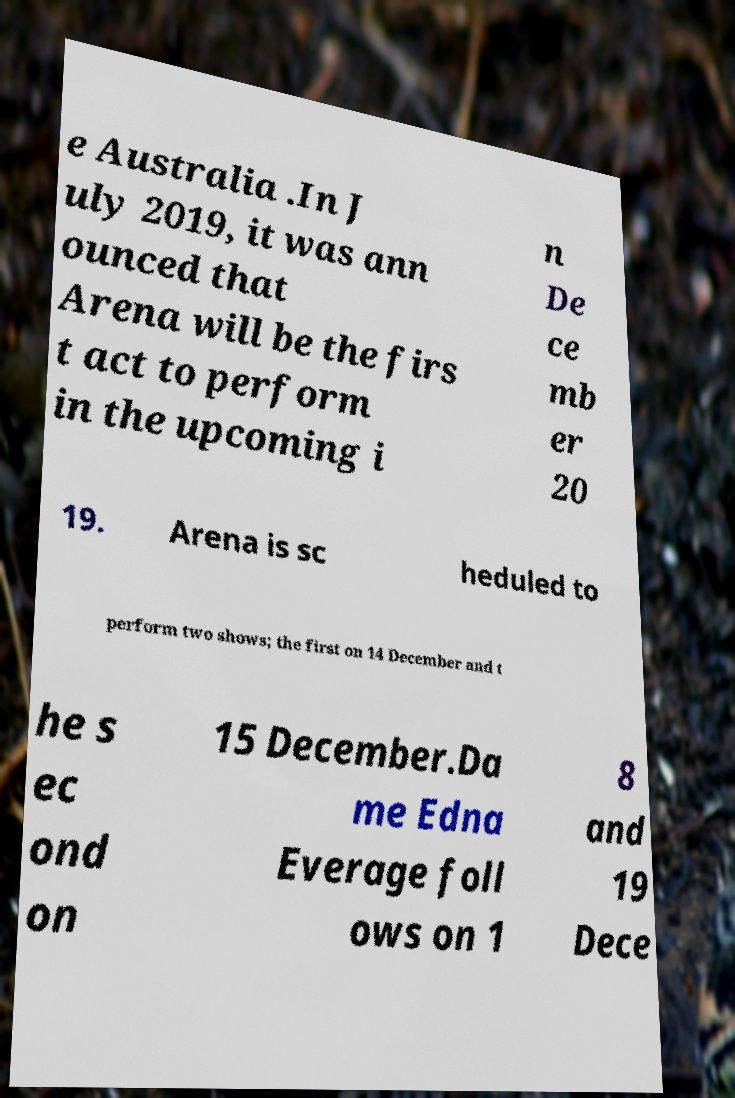Could you assist in decoding the text presented in this image and type it out clearly? e Australia .In J uly 2019, it was ann ounced that Arena will be the firs t act to perform in the upcoming i n De ce mb er 20 19. Arena is sc heduled to perform two shows; the first on 14 December and t he s ec ond on 15 December.Da me Edna Everage foll ows on 1 8 and 19 Dece 